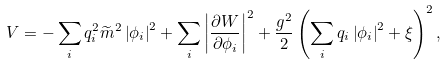Convert formula to latex. <formula><loc_0><loc_0><loc_500><loc_500>V = - \sum _ { i } q _ { i } ^ { 2 } \widetilde { m } ^ { 2 } \left | \phi _ { i } \right | ^ { 2 } + \sum _ { i } \left | \frac { \partial W } { \partial \phi _ { i } } \right | ^ { 2 } + \frac { g ^ { 2 } } { 2 } \left ( \sum _ { i } q _ { i } \left | \phi _ { i } \right | ^ { 2 } + \xi \right ) ^ { 2 } ,</formula> 